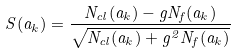<formula> <loc_0><loc_0><loc_500><loc_500>S ( a _ { k } ) = \frac { N _ { c l } ( a _ { k } ) - g N _ { f } ( a _ { k } ) } { \sqrt { N _ { c l } ( a _ { k } ) + g ^ { 2 } N _ { f } ( a _ { k } ) } }</formula> 